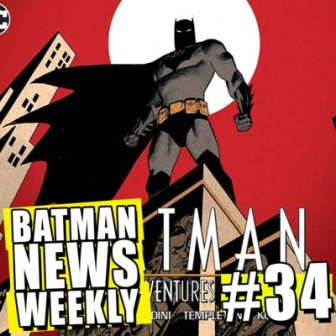Pretend this comic cover is a portal to an alternate universe. Describe what this alternate universe might look like. In this alternate universe, Gotham City is a sprawling metropolis built vertically, with towering buildings interconnected by sky bridges and neon-lit pathways. The city never sleeps, teeming with advanced technologies juxtaposed with gritty underworld elements. Batman, donning a suit infused with nanotechnology, navigates this high-tech landscape using drones and holographic gadgets. Crime syndicates operate in the shadows of the glittering skyline, their leaders wielding advanced weaponry and cybernetic enhancements. Despite the technological advancements, the city is rife with corruption and danger, and Batman remains its vigilant protector, an unyielding force against the tide of futuristic villainy. 